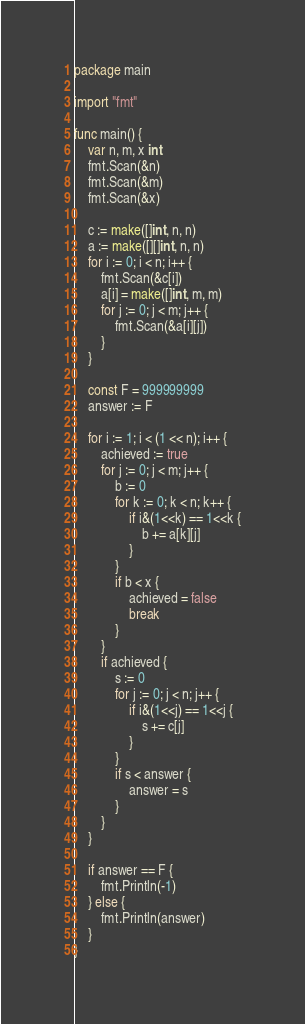<code> <loc_0><loc_0><loc_500><loc_500><_Go_>package main

import "fmt"

func main() {
	var n, m, x int
	fmt.Scan(&n)
	fmt.Scan(&m)
	fmt.Scan(&x)

	c := make([]int, n, n)
	a := make([][]int, n, n)
	for i := 0; i < n; i++ {
		fmt.Scan(&c[i])
		a[i] = make([]int, m, m)
		for j := 0; j < m; j++ {
			fmt.Scan(&a[i][j])
		}
	}

	const F = 999999999
	answer := F

	for i := 1; i < (1 << n); i++ {
		achieved := true
		for j := 0; j < m; j++ {
			b := 0
			for k := 0; k < n; k++ {
				if i&(1<<k) == 1<<k {
					b += a[k][j]
				}
			}
			if b < x {
				achieved = false
				break
			}
		}
		if achieved {
			s := 0
			for j := 0; j < n; j++ {
				if i&(1<<j) == 1<<j {
					s += c[j]
				}
			}
			if s < answer {
				answer = s
			}
		}
	}

	if answer == F {
		fmt.Println(-1)
	} else {
		fmt.Println(answer)
	}
}
</code> 